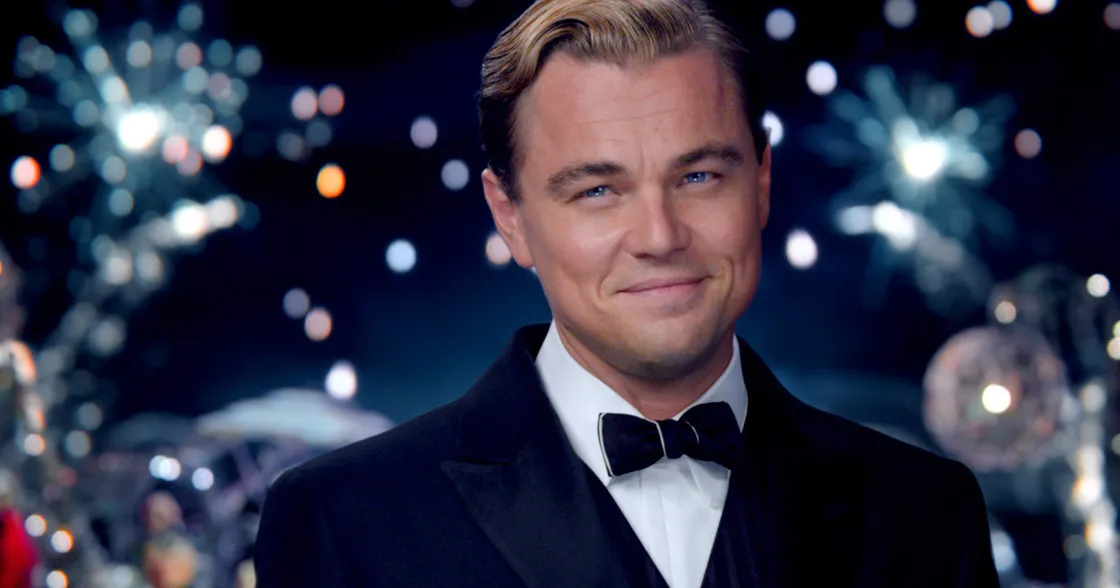What emotions is this character likely experiencing? The character appears to be feeling a blend of contentment and confidence. His slight smile and direct gaze suggest a sense of satisfaction and assurance, potentially reflecting pride or happiness in the moment. The festive backdrop with fireworks and lights might also evoke a sense of celebration or triumph. Can you speculate on the context surrounding this moment for the character? Considering the opulent setting with fireworks and vibrant lights, it is likely that the character is part of a grand celebration, possibly a high-society party. The sophisticated attire and the character's confident demeanor suggest he may be hosting or playing a significant role in the event. He could be enjoying a moment of triumph or recognition, basking in the success of the occasion. 